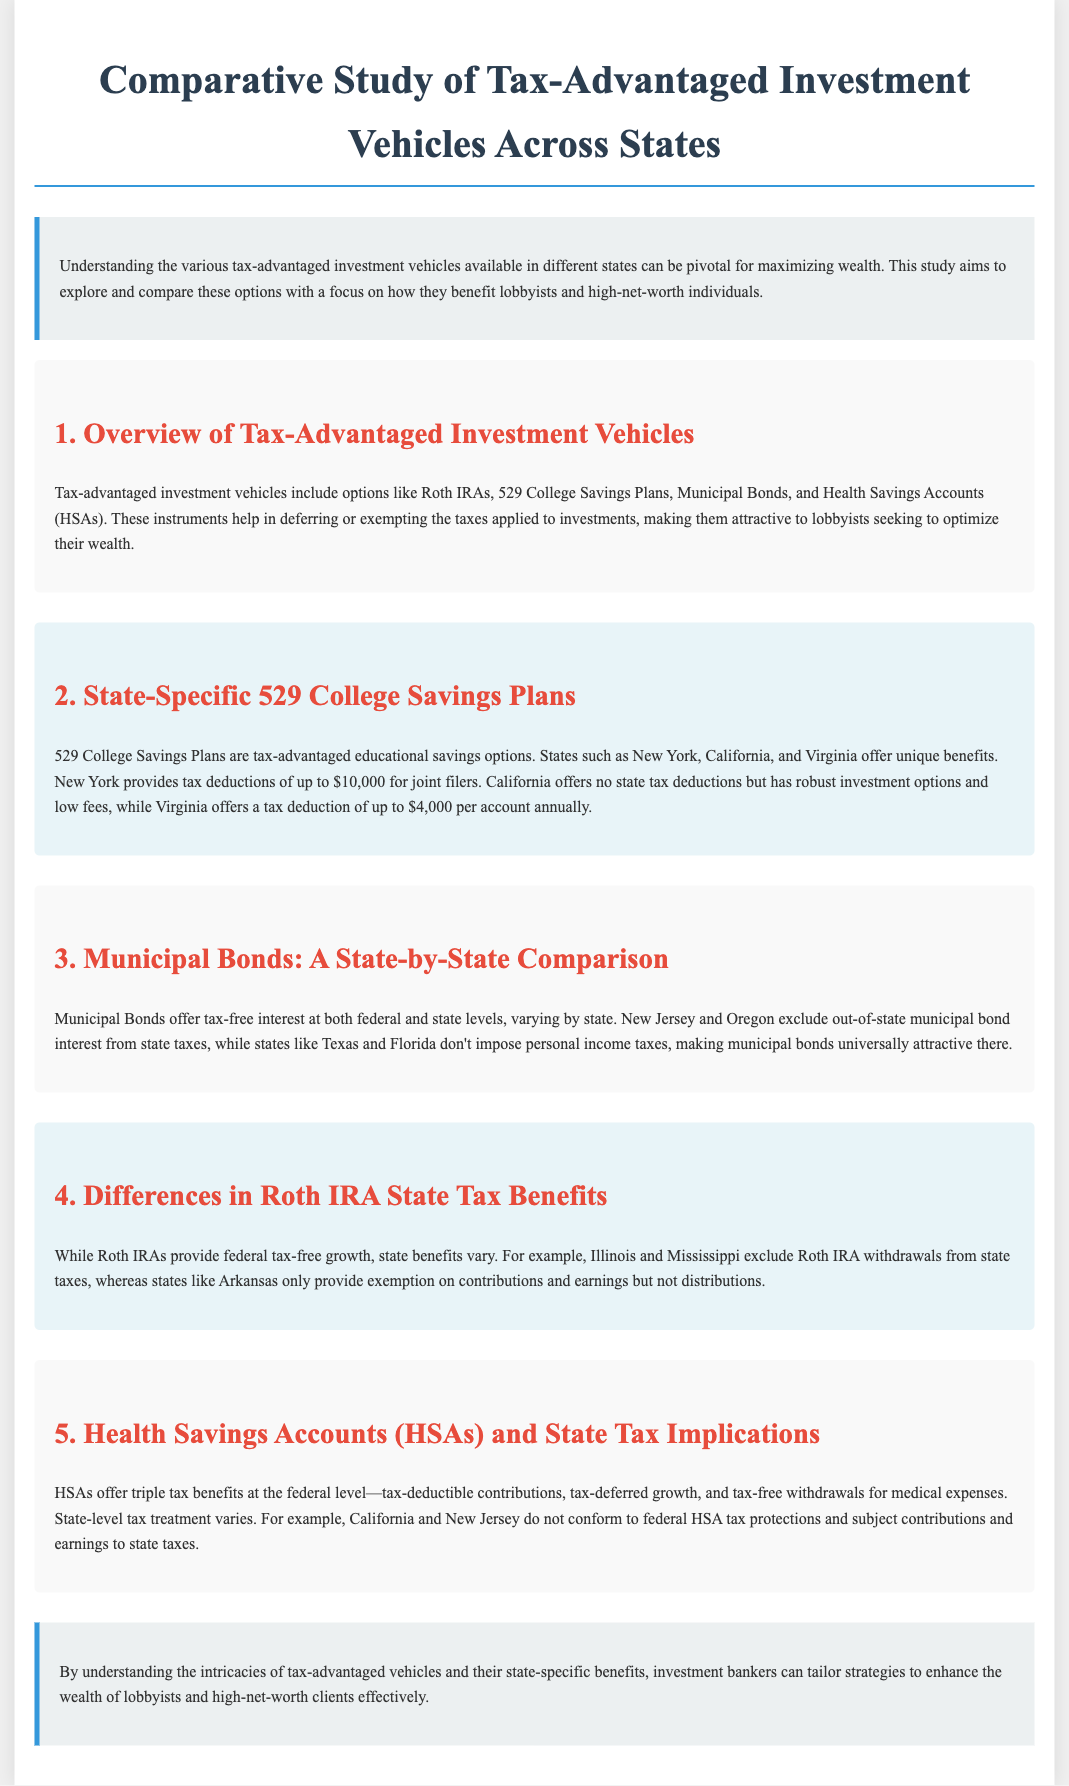What are tax-advantaged investment vehicles? Tax-advantaged investment vehicles include options like Roth IRAs, 529 College Savings Plans, Municipal Bonds, and Health Savings Accounts (HSAs).
Answer: Roth IRAs, 529 College Savings Plans, Municipal Bonds, HSAs What is the New York 529 College Savings Plan tax deduction for joint filers? New York provides tax deductions of up to $10,000 for joint filers.
Answer: $10,000 What do California's 529 College Savings Plans lack? California offers no state tax deductions but has robust investment options and low fees.
Answer: State tax deductions Which states exclude out-of-state municipal bond interest from state taxes? New Jersey and Oregon exclude out-of-state municipal bond interest from state taxes.
Answer: New Jersey, Oregon What tax exemption does Illinois provide for Roth IRA withdrawals? Illinois excludes Roth IRA withdrawals from state taxes.
Answer: Excluded Which states do not conform to federal HSA tax protections? California and New Jersey do not conform to federal HSA tax protections.
Answer: California, New Jersey What key advantage do HSAs provide at the federal level? HSAs offer triple tax benefits at the federal level.
Answer: Triple tax benefits What is the maximum tax deduction offered by Virginia's 529 College Savings Plan annually? Virginia offers a tax deduction of up to $4,000 per account annually.
Answer: $4,000 